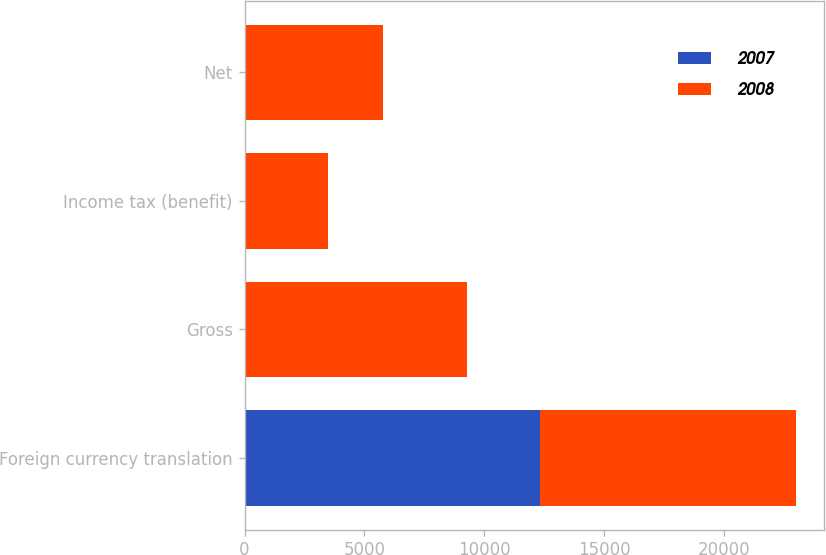<chart> <loc_0><loc_0><loc_500><loc_500><stacked_bar_chart><ecel><fcel>Foreign currency translation<fcel>Gross<fcel>Income tax (benefit)<fcel>Net<nl><fcel>2007<fcel>12314<fcel>32<fcel>12<fcel>20<nl><fcel>2008<fcel>10677<fcel>9252<fcel>3482<fcel>5770<nl></chart> 